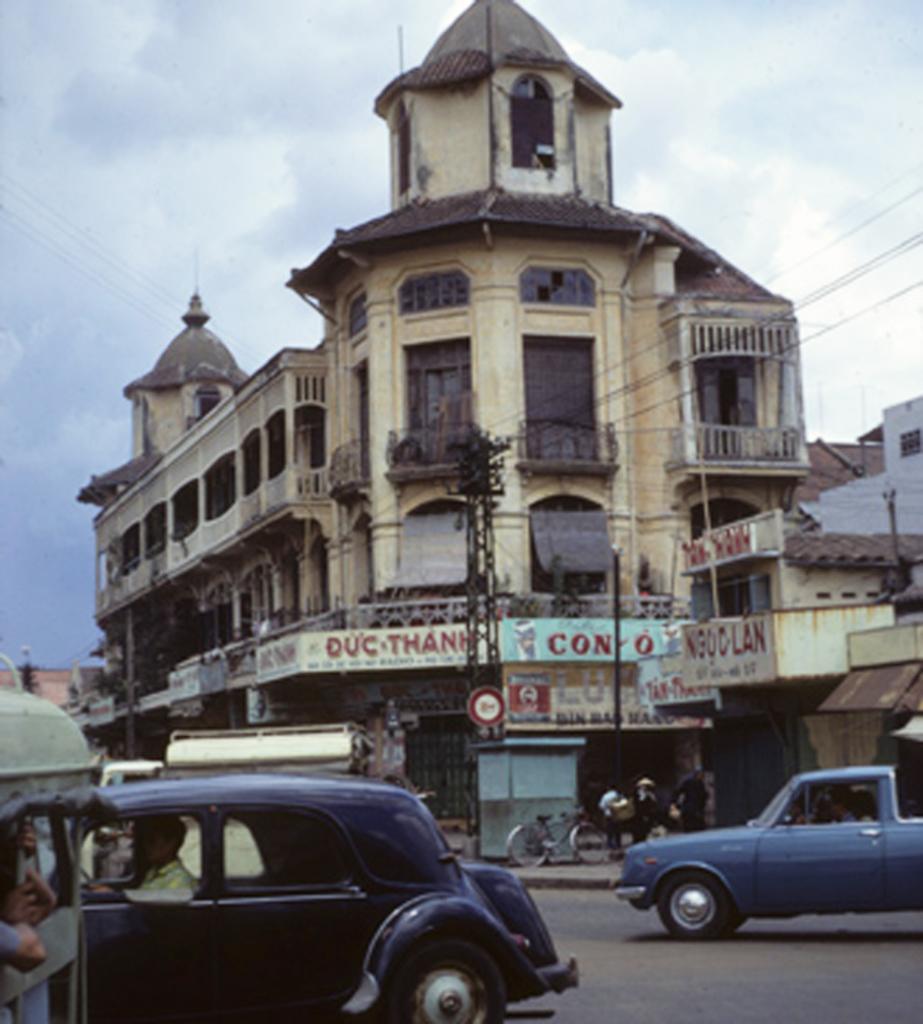How would you summarize this image in a sentence or two? There is a road. On the road there are many vehicles. In the back there are buildings with windows, pillars, balcony. Also there are name boards. In the background there is sky with clouds. 